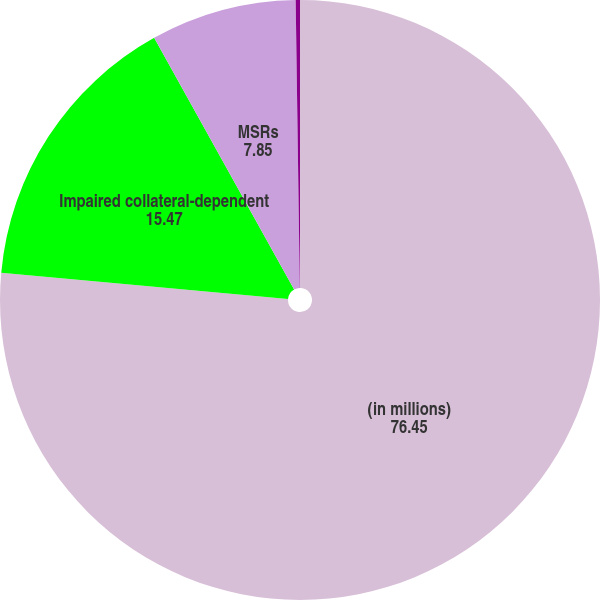Convert chart to OTSL. <chart><loc_0><loc_0><loc_500><loc_500><pie_chart><fcel>(in millions)<fcel>Impaired collateral-dependent<fcel>MSRs<fcel>Foreclosed assets<nl><fcel>76.45%<fcel>15.47%<fcel>7.85%<fcel>0.23%<nl></chart> 